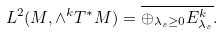<formula> <loc_0><loc_0><loc_500><loc_500>L ^ { 2 } ( M , \wedge ^ { k } T ^ { * } M ) = \overline { \oplus _ { \lambda _ { s } \geq 0 } E ^ { k } _ { \lambda _ { s } } } .</formula> 